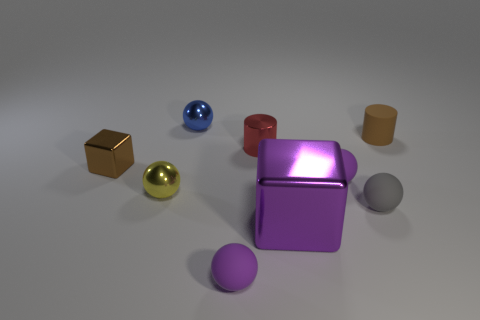What is the material of the tiny cylinder that is the same color as the tiny metallic block?
Your answer should be compact. Rubber. What number of blocks are either small brown shiny objects or small red metallic objects?
Ensure brevity in your answer.  1. Are the tiny brown cube and the tiny brown cylinder made of the same material?
Ensure brevity in your answer.  No. What number of other objects are the same color as the matte cylinder?
Give a very brief answer. 1. There is a small brown thing to the right of the brown shiny object; what shape is it?
Provide a short and direct response. Cylinder. What number of objects are big gray matte objects or brown cylinders?
Provide a short and direct response. 1. Do the purple block and the ball behind the small block have the same size?
Give a very brief answer. No. What number of other objects are there of the same material as the small red cylinder?
Give a very brief answer. 4. What number of objects are either small shiny objects on the right side of the tiny brown block or tiny things that are in front of the tiny yellow ball?
Give a very brief answer. 5. What is the material of the big purple thing that is the same shape as the brown metallic thing?
Your answer should be very brief. Metal. 